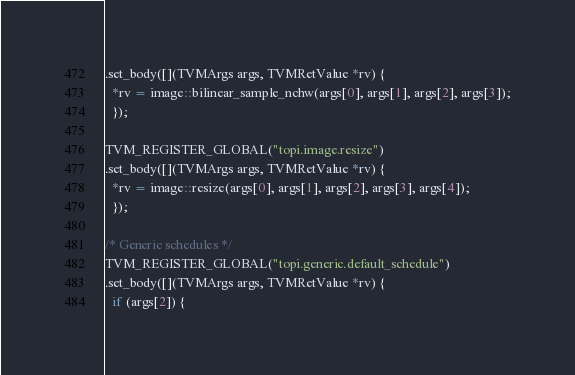<code> <loc_0><loc_0><loc_500><loc_500><_C++_>.set_body([](TVMArgs args, TVMRetValue *rv) {
  *rv = image::bilinear_sample_nchw(args[0], args[1], args[2], args[3]);
  });

TVM_REGISTER_GLOBAL("topi.image.resize")
.set_body([](TVMArgs args, TVMRetValue *rv) {
  *rv = image::resize(args[0], args[1], args[2], args[3], args[4]);
  });

/* Generic schedules */
TVM_REGISTER_GLOBAL("topi.generic.default_schedule")
.set_body([](TVMArgs args, TVMRetValue *rv) {
  if (args[2]) {</code> 